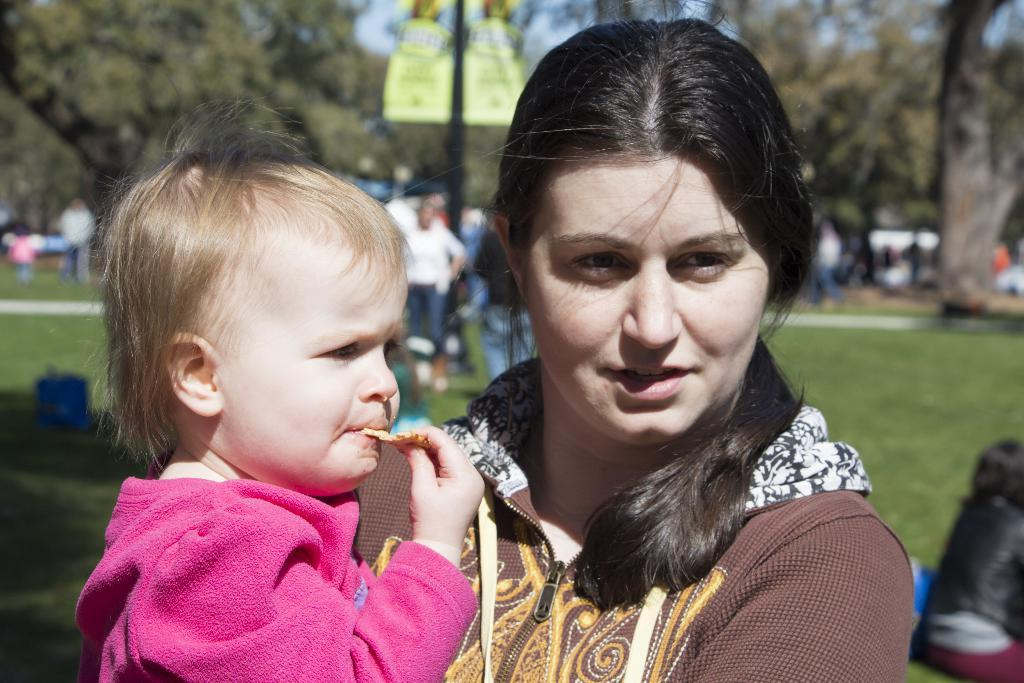Who is the main subject in the image? There is a woman in the image. What is the woman doing in the image? The woman is holding a kid. What is the kid wearing in the image? The kid is wearing a pink jacket. What can be seen in the background of the image? There are many trees and people in the background of the image. What is the color of the grass at the bottom of the image? The grass at the bottom of the image is green. What type of growth can be seen on the trees in the image? There is no indication of growth on the trees in the image; we can only see their presence in the background. What thought is the woman having while holding the kid in the image? There is no way to determine the woman's thoughts from the image alone. 